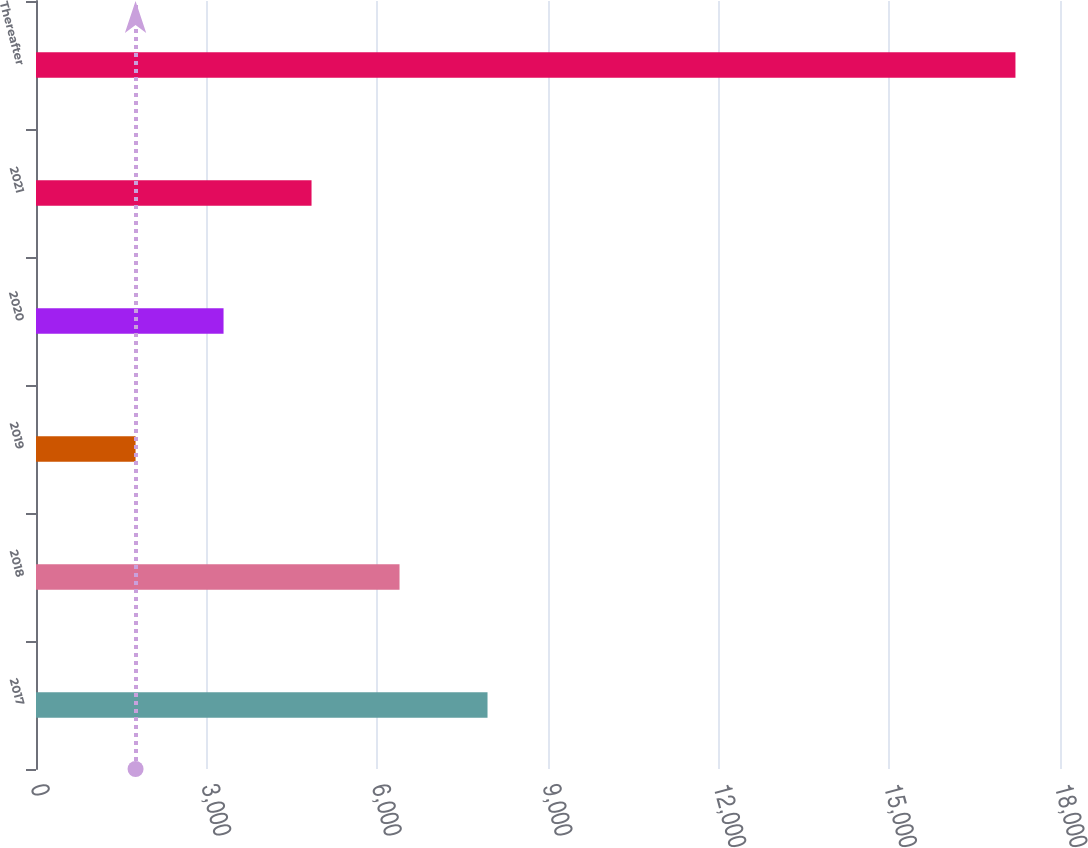<chart> <loc_0><loc_0><loc_500><loc_500><bar_chart><fcel>2017<fcel>2018<fcel>2019<fcel>2020<fcel>2021<fcel>Thereafter<nl><fcel>7936.8<fcel>6390.1<fcel>1750<fcel>3296.7<fcel>4843.4<fcel>17217<nl></chart> 